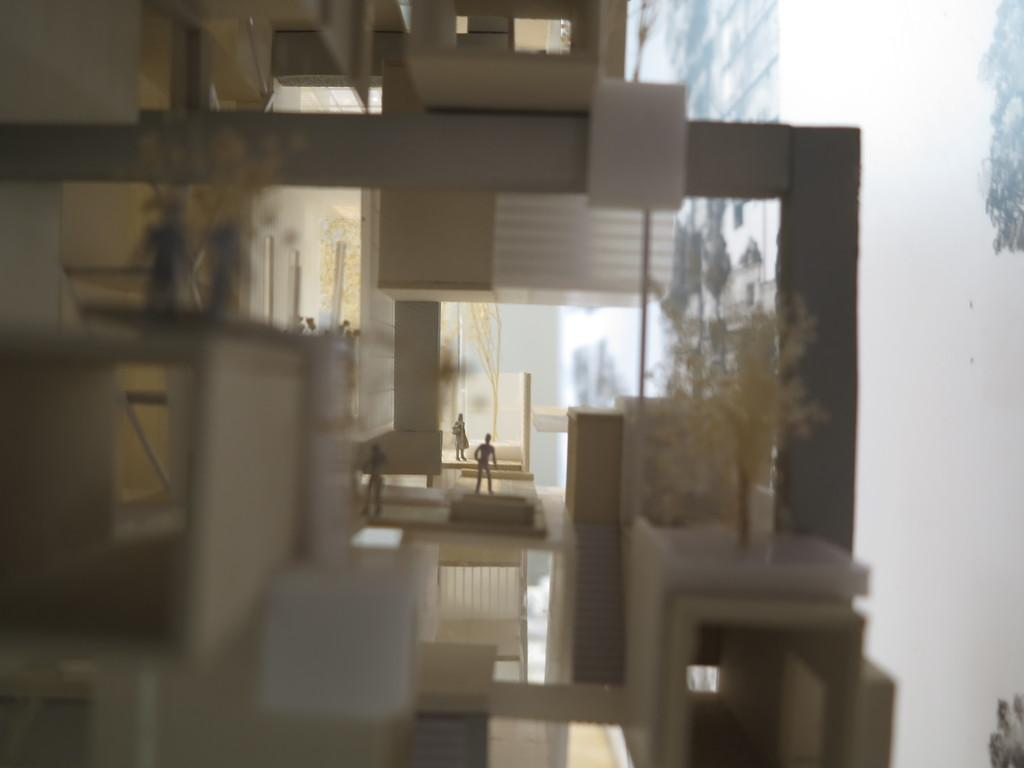What is the main subject of the image? The main subject of the image is a miniature of a building. What can be seen in the foreground of the image? There are two plants in the front of the image. How many people are visible in the background of the image? There are three persons standing in the background of the image. What architectural feature is present on the right side of the image? There are stairs on the right side of the image. What type of straw is being used by the boys in the image? There are no boys or straws present in the image. 